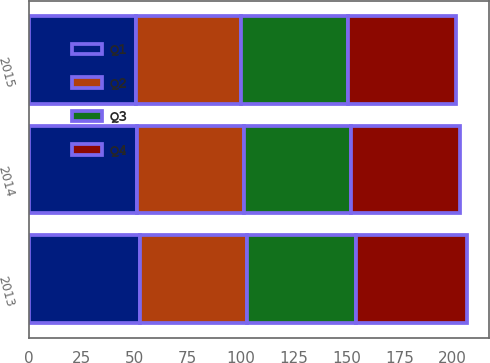<chart> <loc_0><loc_0><loc_500><loc_500><stacked_bar_chart><ecel><fcel>2015<fcel>2014<fcel>2013<nl><fcel>Q4<fcel>50.8<fcel>51.2<fcel>52.3<nl><fcel>Q1<fcel>50.3<fcel>50.8<fcel>52.2<nl><fcel>Q3<fcel>50.5<fcel>50.8<fcel>51.7<nl><fcel>Q2<fcel>49.9<fcel>50.5<fcel>50.6<nl></chart> 